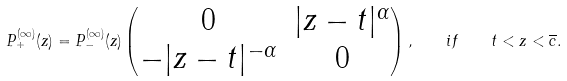Convert formula to latex. <formula><loc_0><loc_0><loc_500><loc_500>P ^ { ( \infty ) } _ { + } ( z ) = P ^ { ( \infty ) } _ { - } ( z ) \begin{pmatrix} 0 & | z - t | ^ { \alpha } \\ - | z - t | ^ { - \alpha } & 0 \end{pmatrix} , \quad i f \quad t < z < \overline { c } .</formula> 